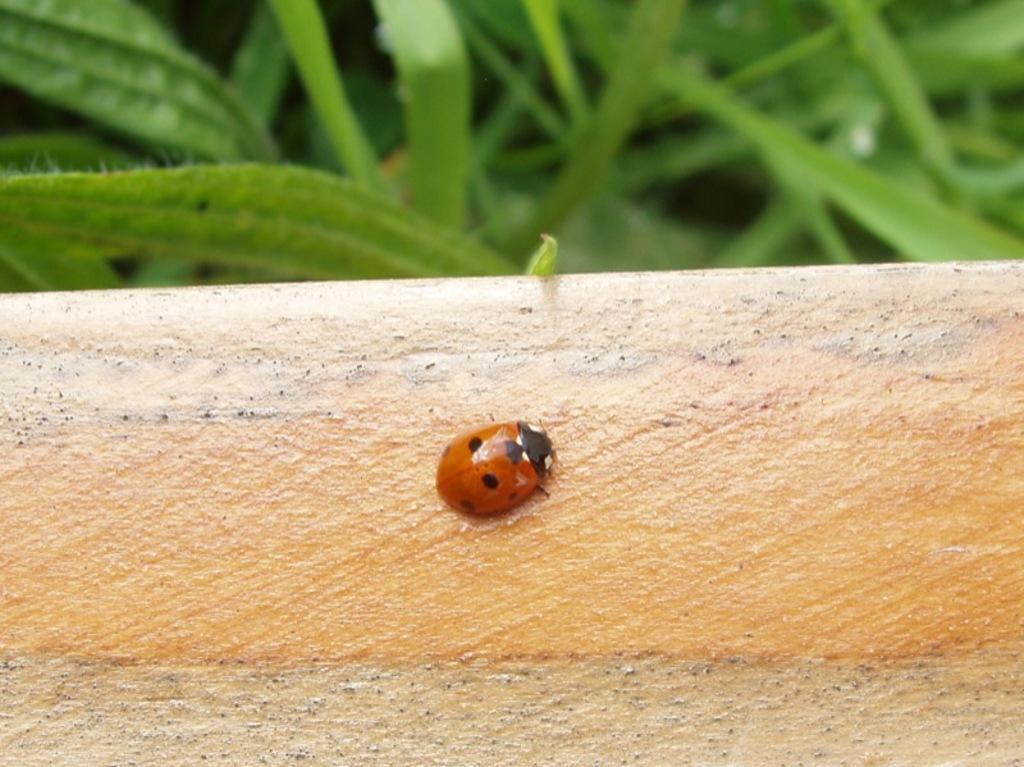Please provide a concise description of this image. There is a bug on a surface. In the back there are leaves. 